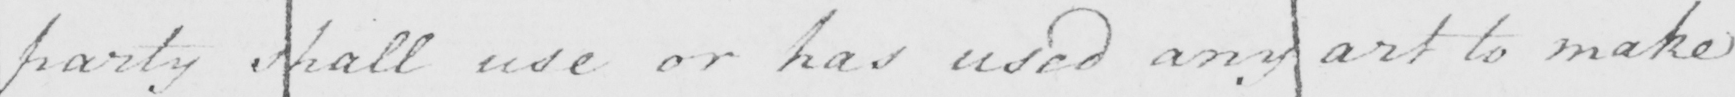Can you read and transcribe this handwriting? party shall use or has used any art to make 